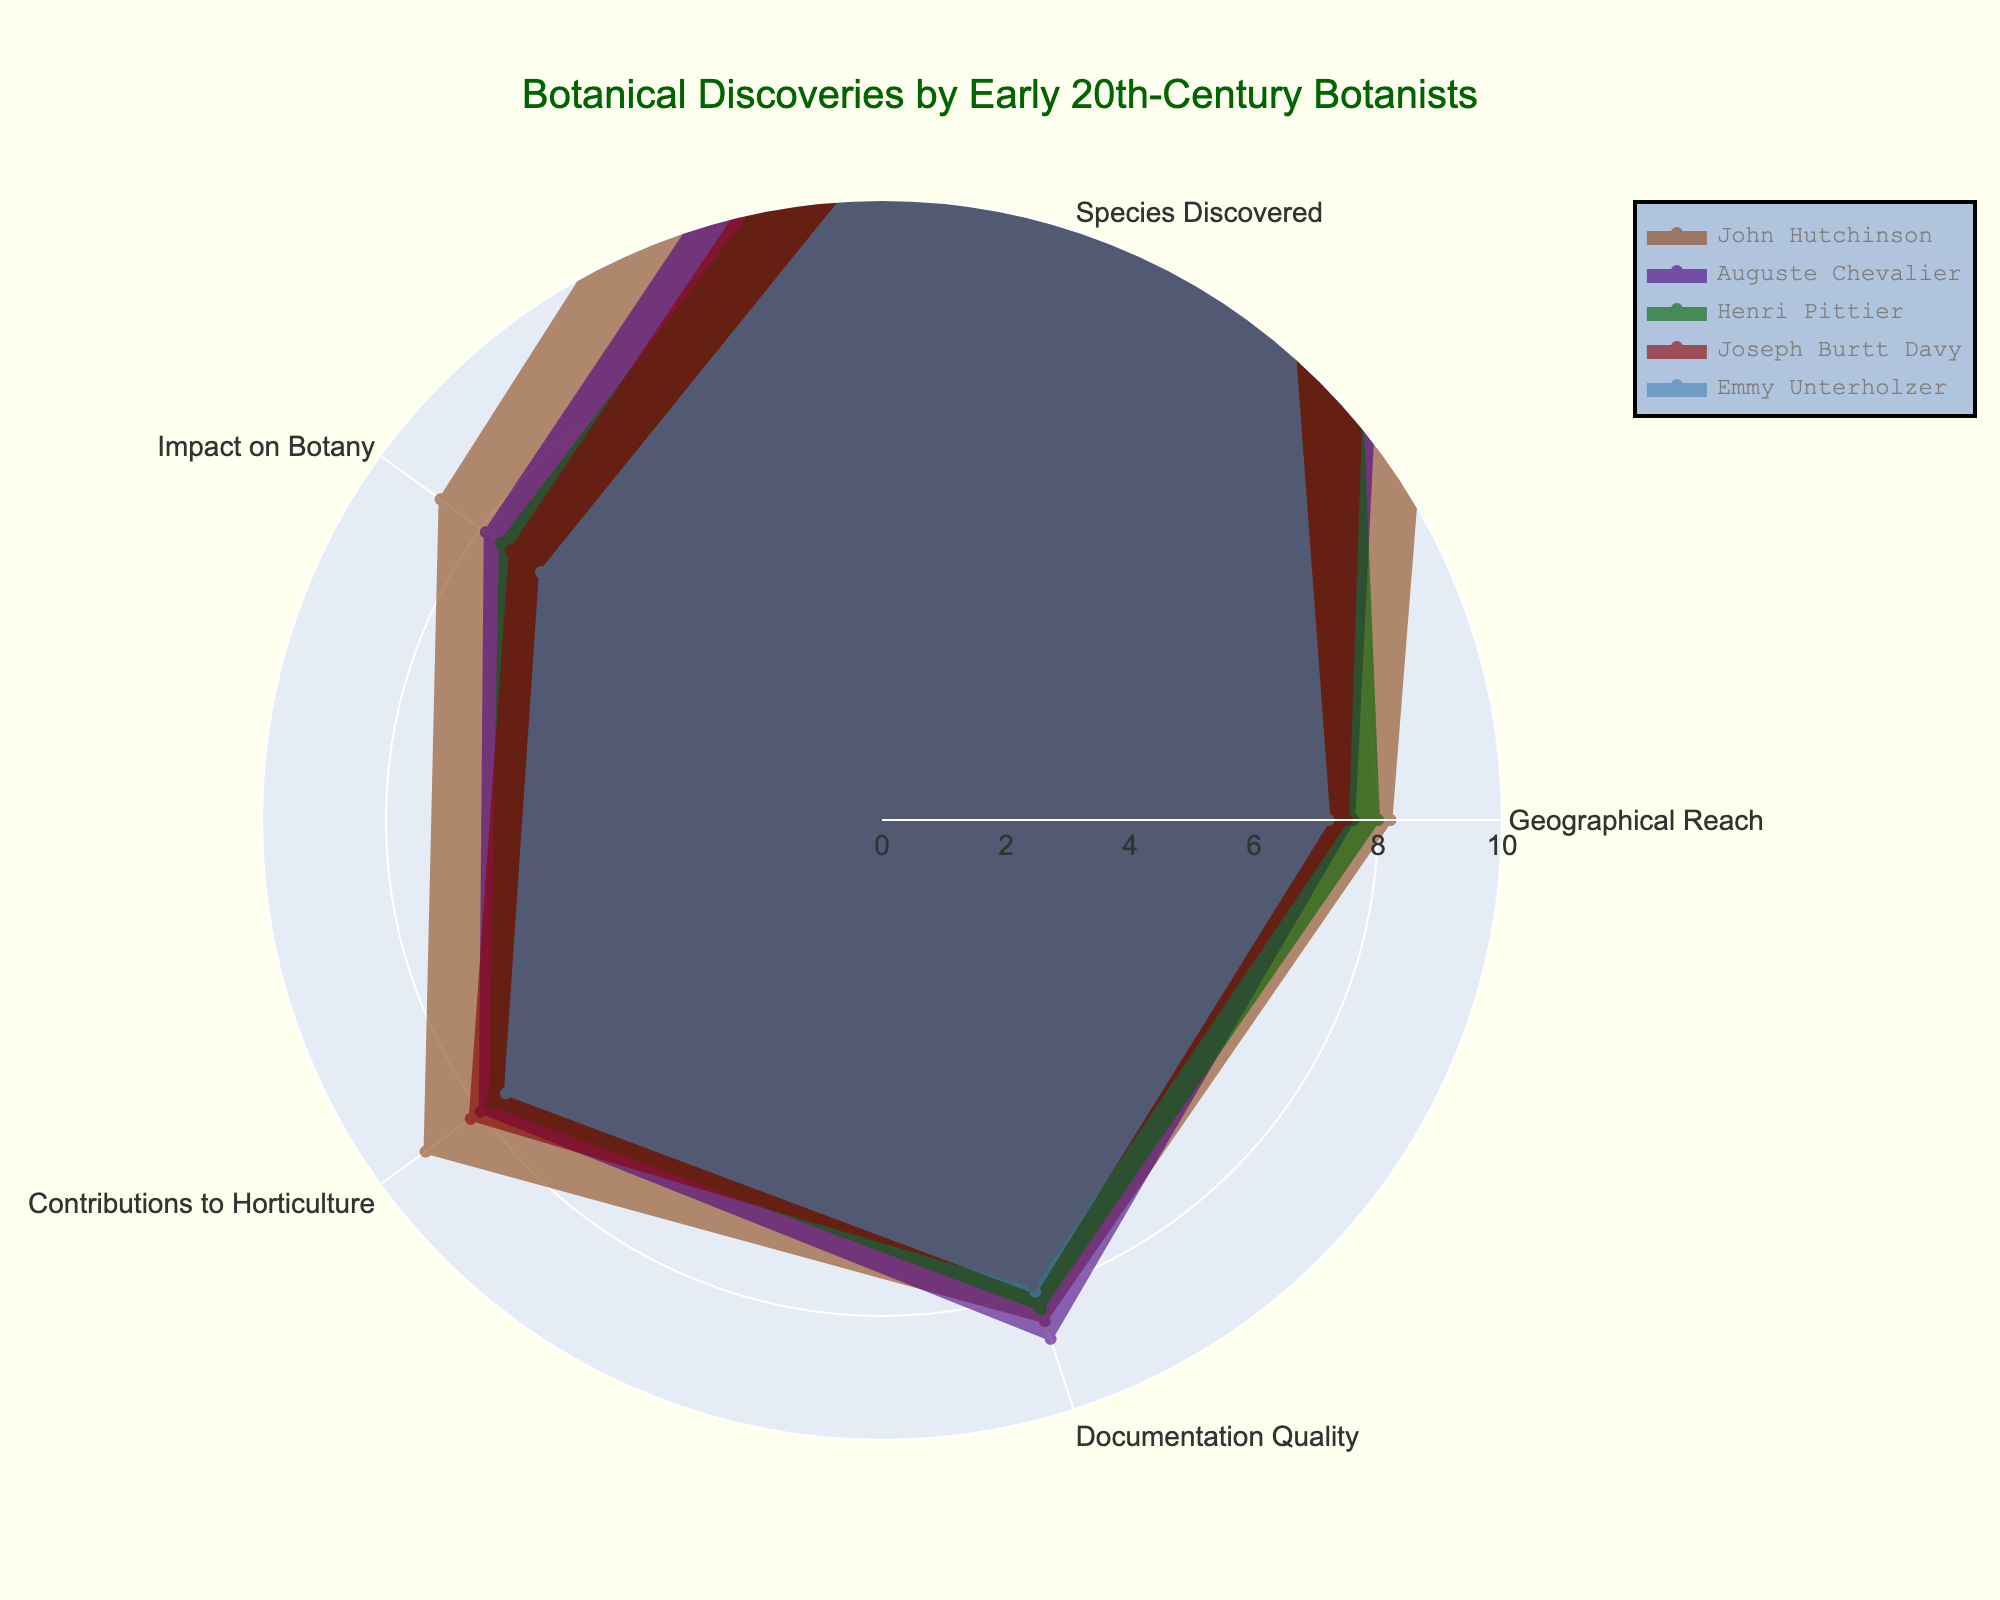What is the title of the radar chart? The title is prominently displayed at the top of the chart, which reads "Botanical Discoveries by Early 20th-Century Botanists".
Answer: Botanical Discoveries by Early 20th-Century Botanists Which botanist has the highest value for "Contributions to Horticulture"? By visually comparing the "Contributions to Horticulture" axis, John Hutchinson's value extends the furthest along this dimension.
Answer: John Hutchinson What are the two categories with the highest values for Auguste Chevalier? By examining the radar chart, Auguste Chevalier has the highest values in "Documentation Quality" and "Contributions to Horticulture" based on the length of the axes.
Answer: Documentation Quality and Contributions to Horticulture Among the botanists, who discovered the most species? By looking at the "Species Discovered" axis, John Hutchinson's value is the highest, indicating he discovered the most species.
Answer: John Hutchinson What is the average impact on botany among all botanists? The values for "Impact on Botany" are 8.8, 7.9, 7.6, 7.4, and 6.8. Summing these gives 38.5, and dividing by 5 gives the average of 7.7.
Answer: 7.7 How is Emmy Unterholzer's geographical reach compared to the average? Emmy Unterholzer has a geographical reach of 7.2. The average geographical reach can be calculated by averaging 8.2, 7.6, 8.0, 7.5, and 7.2, which totals 38.5, divided by 5 is 7.7, indicating she is below average.
Answer: Below average Which botanist has the most balanced contributions across all categories? By visually comparing the extent of each botanist's values across all categories, John Hutchinson seems the most balanced with all high values closely clustered.
Answer: John Hutchinson How does Joseph Burtt Davy's "Documentation Quality" compare with the overall highest in this category? Joseph Burtt Davy has a "Documentation Quality" value of 7.9, whereas the highest value is 8.8 by Auguste Chevalier. Joseph's value is lower than the highest by 0.9.
Answer: Lower by 0.9 Which botanist's total score (sum of all categories) is the highest? Summing the values for each botanist, John Hutchinson has (8.2 + 35 + 8.8 + 9.1 + 8.5) = 69.6, which is the highest total score compared to others.
Answer: John Hutchinson 